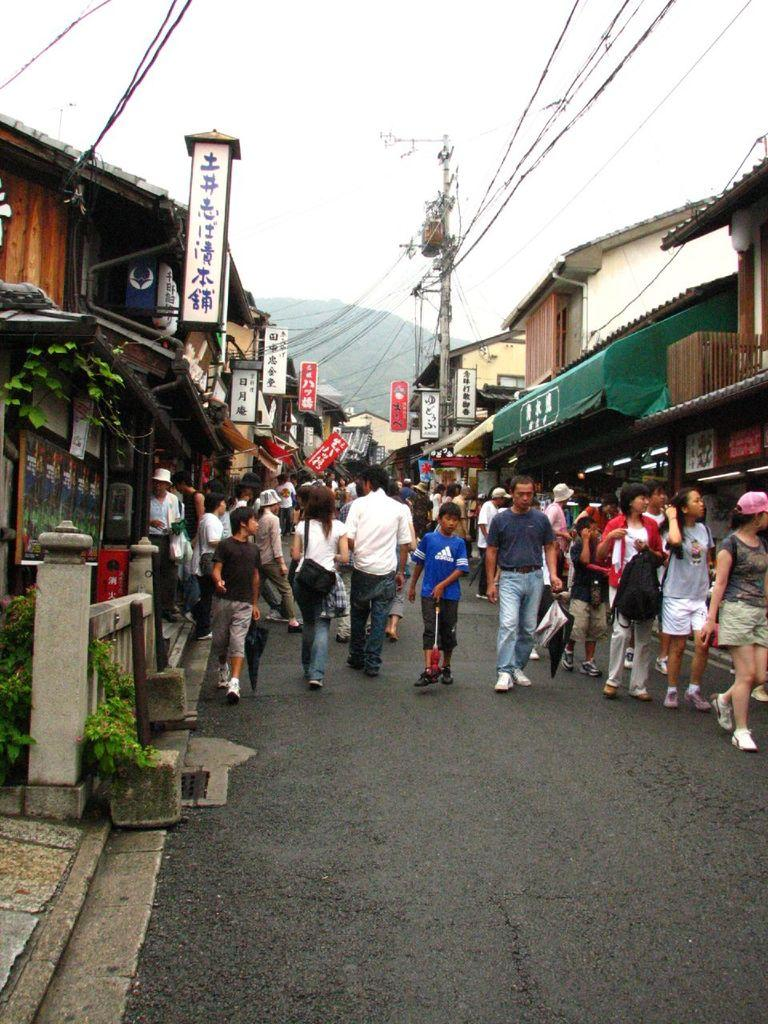How many people are in the image? There is a group of people in the image. What are the people in the image doing? Some people are standing, while others are walking on the road. What can be seen in the background of the image? There are hoardings, houses, plants, and a pole with cables visible in the image. What type of hat is the person in the image wearing? There is no person wearing a hat in the image. In which direction are the people in the image facing, towards the north or south? The image does not provide information about the direction the people are facing, nor is there any indication of north or south in the image. 